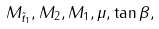Convert formula to latex. <formula><loc_0><loc_0><loc_500><loc_500>M _ { \tilde { t } _ { 1 } } , M _ { 2 } , M _ { 1 } , \mu , \tan \beta ,</formula> 